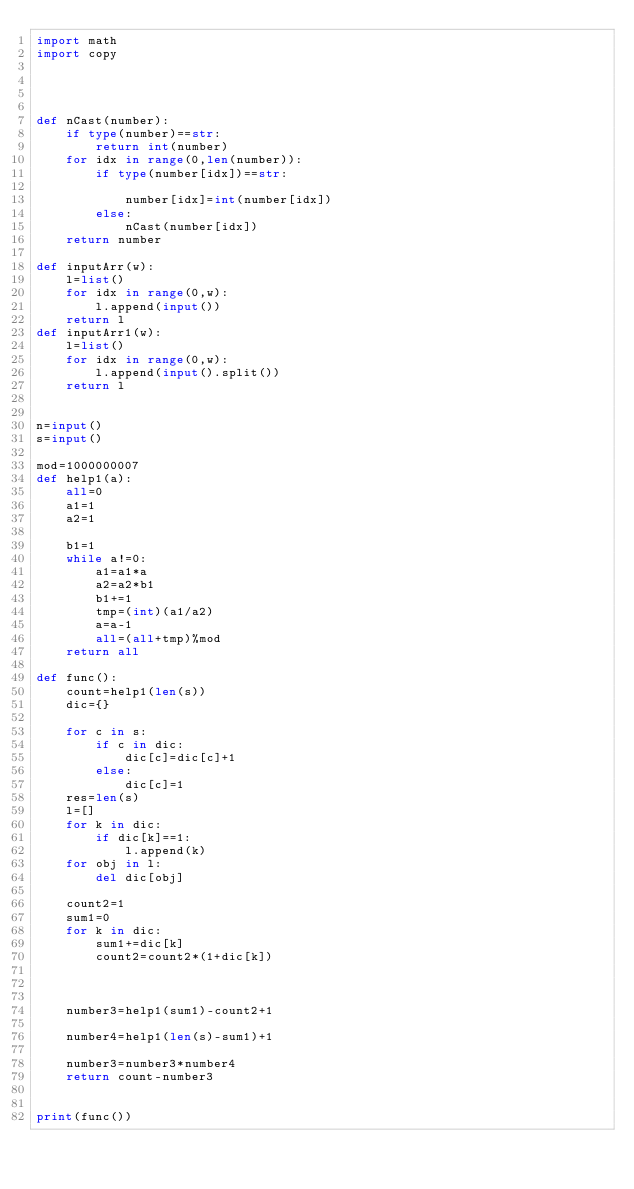Convert code to text. <code><loc_0><loc_0><loc_500><loc_500><_Python_>import math
import copy
 
 
 
 
def nCast(number):
    if type(number)==str:
        return int(number)
    for idx in range(0,len(number)):
        if type(number[idx])==str:
 
            number[idx]=int(number[idx])
        else:
            nCast(number[idx])
    return number
    
def inputArr(w):
    l=list()
    for idx in range(0,w):
        l.append(input())
    return l
def inputArr1(w):
    l=list()
    for idx in range(0,w):
        l.append(input().split())
    return l
 

n=input()
s=input()

mod=1000000007
def help1(a):
    all=0
    a1=1
    a2=1
    
    b1=1
    while a!=0:
        a1=a1*a
        a2=a2*b1
        b1+=1
        tmp=(int)(a1/a2)
        a=a-1
        all=(all+tmp)%mod
    return all

def func():
    count=help1(len(s))
    dic={}

    for c in s:
        if c in dic:
            dic[c]=dic[c]+1
        else:
            dic[c]=1
    res=len(s)
    l=[]
    for k in dic:
        if dic[k]==1:
            l.append(k)
    for obj in l:
        del dic[obj]
        
    count2=1
    sum1=0
    for k in dic:
        sum1+=dic[k]
        count2=count2*(1+dic[k])



    number3=help1(sum1)-count2+1

    number4=help1(len(s)-sum1)+1

    number3=number3*number4
    return count-number3
  

print(func())
</code> 